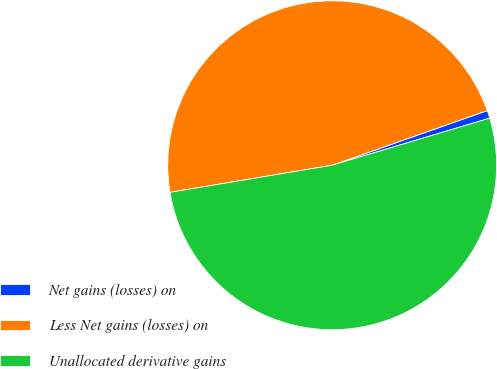Convert chart to OTSL. <chart><loc_0><loc_0><loc_500><loc_500><pie_chart><fcel>Net gains (losses) on<fcel>Less Net gains (losses) on<fcel>Unallocated derivative gains<nl><fcel>0.77%<fcel>47.25%<fcel>51.98%<nl></chart> 